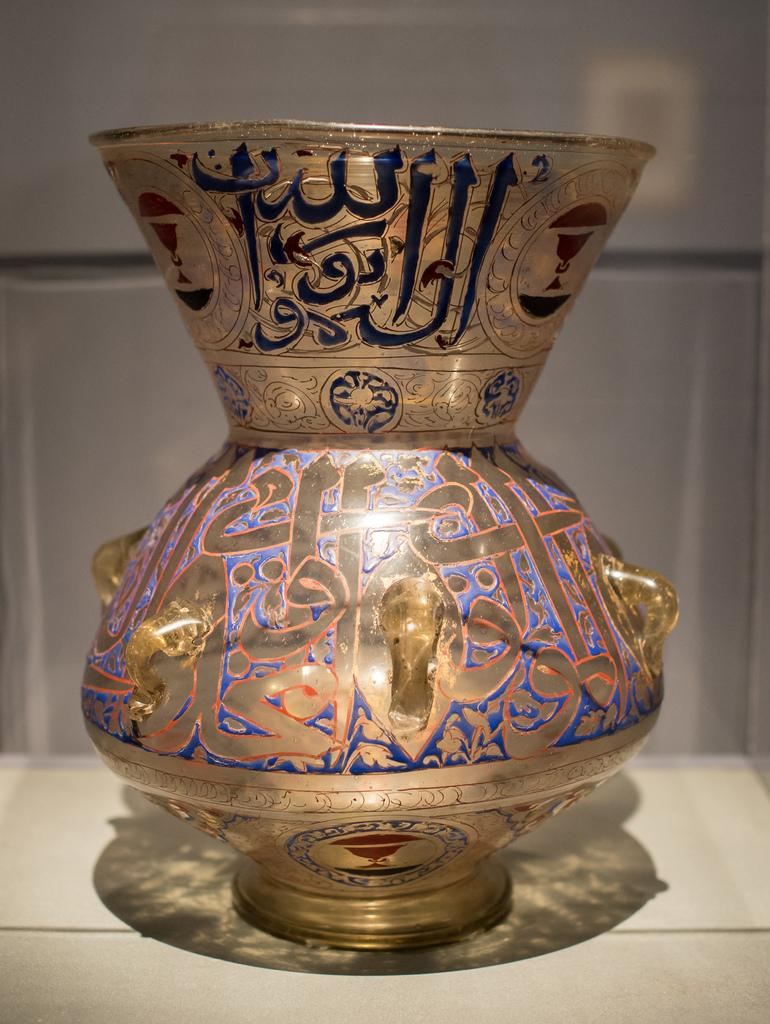What object can be seen in the image? There is a vase in the image. What is featured on the vase? There is writing on the vase. Can you tell me how many women are holding the baby on the bike in the image? There are no women, babies, or bikes present in the image; it only features a vase with writing on it. 